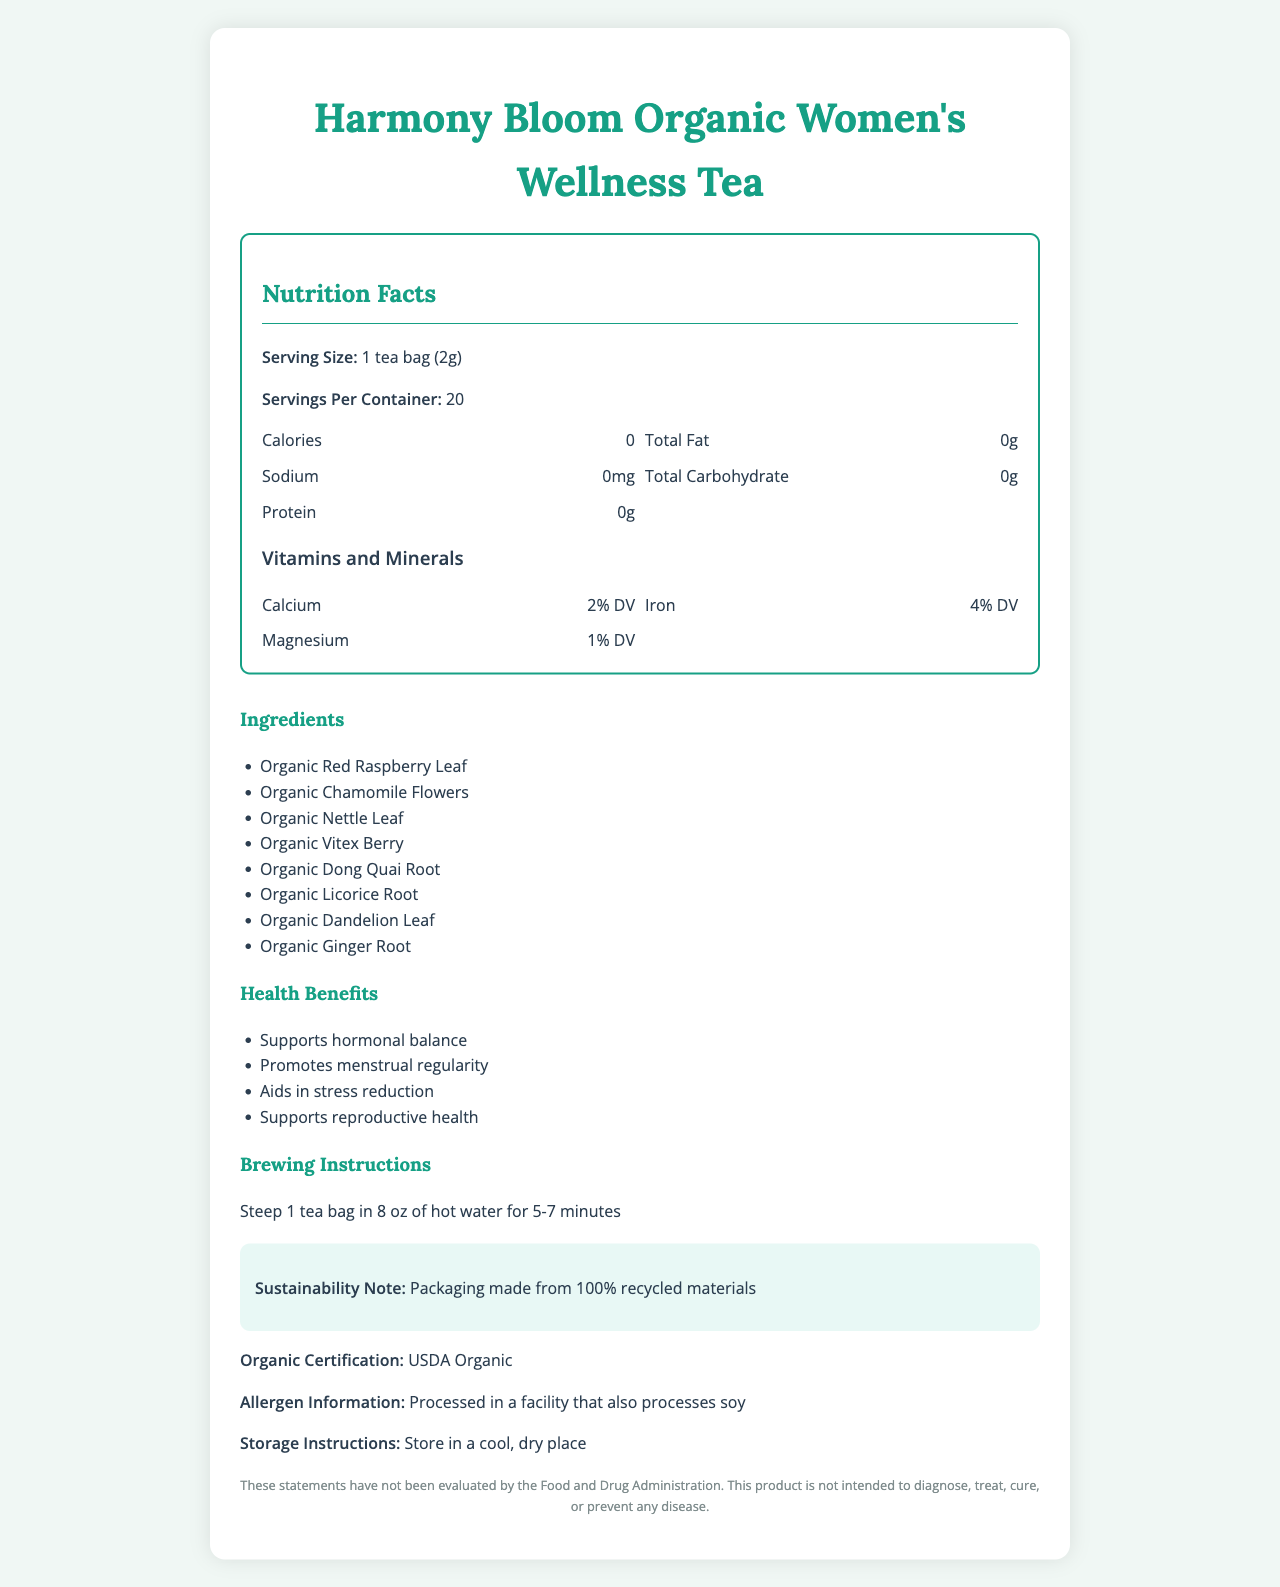what is the serving size for Harmony Bloom Organic Women's Wellness Tea? The serving size is mentioned in the "Nutrition Facts" section as "Serving Size: 1 tea bag (2g)".
Answer: 1 tea bag (2g) how many servings are there per container? The container contains 20 servings as listed under "Servings Per Container".
Answer: 20 which ingredient contributes to supporting hormonal balance in the tea blend? "Organic Vitex Berry" is listed as one of the ingredients and is known to support hormonal balance.
Answer: Organic Vitex Berry how many calories are there per serving? The "Calories" listed in the "Nutrition Facts" section indicate 0 calories per serving.
Answer: 0 which mineral is present in the highest daily value percentage? Iron is listed with a 4% daily value (DV) in the "Vitamins and Minerals" section, which is the highest compared to Calcium and Magnesium.
Answer: Iron which of the following is NOT an ingredient in the tea? A. Organic Chamomile Flowers B. Organic Licorice Root C. Organic Ginger Root D. Organic Lemon Balm The ingredients section lists Organic Chamomile Flowers, Organic Licorice Root, and Organic Ginger Root, but not Organic Lemon Balm.
Answer: D. Organic Lemon Balm what are the key health benefits promoted by this tea? A. Supports weight loss B. Supports reproductive health C. Improves eye vision D. Promotes menstrual regularity The health benefits section mentions "Supports reproductive health" and "Promotes menstrual regularity" explicitly.
Answer: B. Supports reproductive health is this product certified organic? The document states "Organic Certification: USDA Organic," confirming the product's organic certification.
Answer: Yes describe the main information conveyed in the Harmony Bloom Organic Women's Wellness Tea document. The explanation helps summarize all the key elements and sections presented in the document.
Answer: The document provides detailed information about Harmony Bloom Organic Women's Wellness Tea, including its serving size, number of servings per container, nutrition facts (e.g., calories, fats, sodium, carbohydrates, proteins), and the vitamins and minerals it contains. It lists the ingredients used in the tea blend, such as Organic Red Raspberry Leaf, Organic Chamomile Flowers, and Organic Dong Quai Root, among others. The document highlights the health benefits associated with the tea, such as supporting hormonal balance and stress reduction. Additionally, it includes brewing instructions, organic certification, allergen information, storage instructions, and sustainability notes. It ends with a disclaimer about the product's health claims. what are the antioxidants present in this tea blend? The antioxidants section lists Flavonoids and Polyphenols as the antioxidants contained in the tea blend.
Answer: Flavonoids, Polyphenols what does the sustainability note mention about the packaging? The document notes that the packaging is made from 100% recycled materials in the sustainability section.
Answer: Packaging made from 100% recycled materials how many milligrams of caffeine are in one serving of the tea? The document states "caffeine content: 0mg," indicating that the tea is caffeine-free.
Answer: 0mg how should this tea be stored? The storage instructions specify to store the tea in a cool, dry place.
Answer: Store in a cool, dry place does this tea contain any protein? The "Protein" section in the Nutrition Facts lists 0g of protein.
Answer: No does the document provide specific medicinal uses or diseases the tea can cure? The disclaimer at the end of the document specifies, "This product is not intended to diagnose, treat, cure, or prevent any disease," indicating it does not make specific medicinal claims.
Answer: No what percentage of daily value (DV) of calcium is provided in one serving of this tea? The "Vitamins and Minerals" section lists Calcium with a 2% daily value.
Answer: 2% DV what are the health benefits of this tea? The health benefits section lists these specific benefits of the tea.
Answer: Supports hormonal balance, Promotes menstrual regularity, Aids in stress reduction, Supports reproductive health can we determine the processing date of the tea from the document? The document does not provide any details about the processing or manufacturing date of the tea.
Answer: Not enough information 